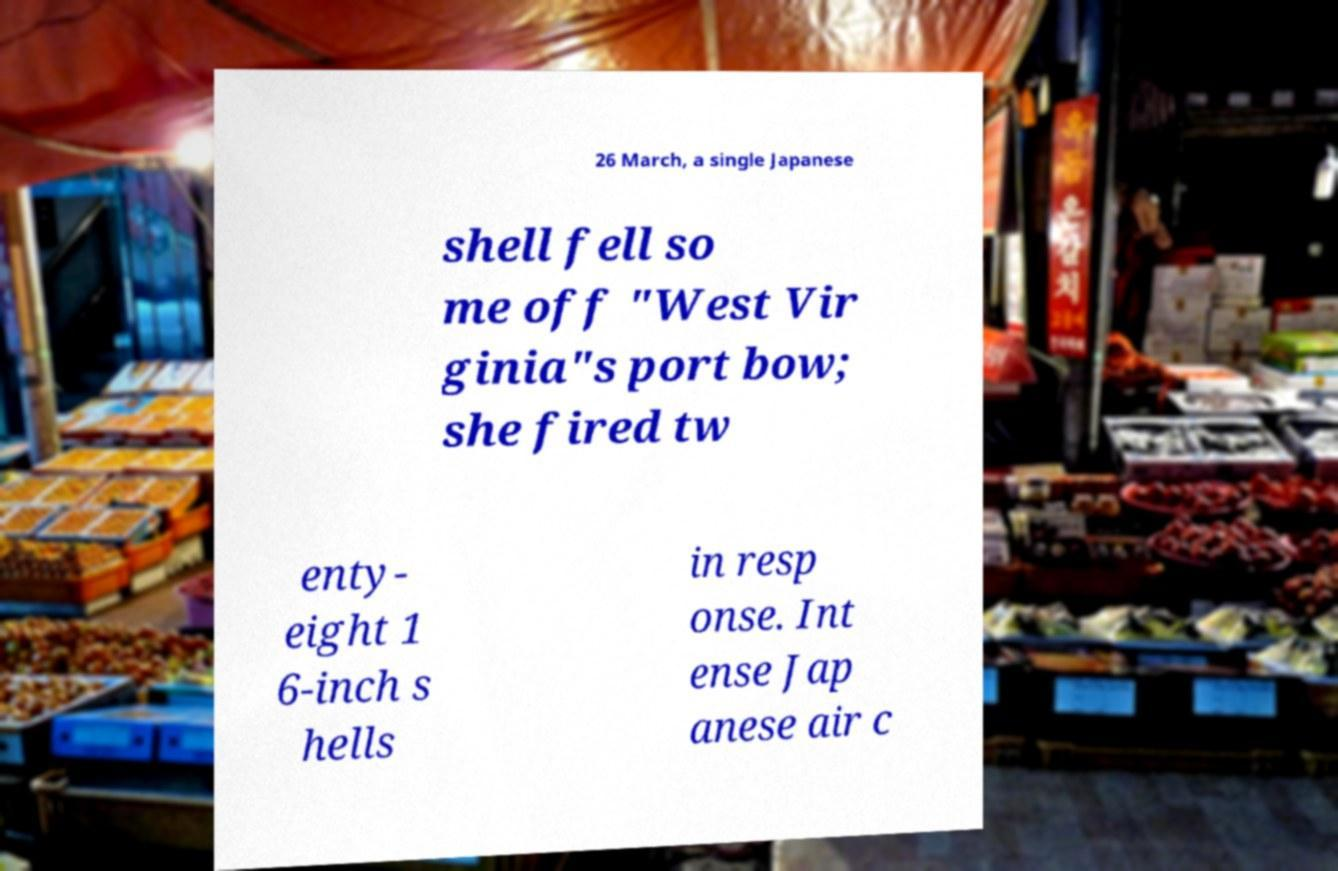What messages or text are displayed in this image? I need them in a readable, typed format. 26 March, a single Japanese shell fell so me off "West Vir ginia"s port bow; she fired tw enty- eight 1 6-inch s hells in resp onse. Int ense Jap anese air c 